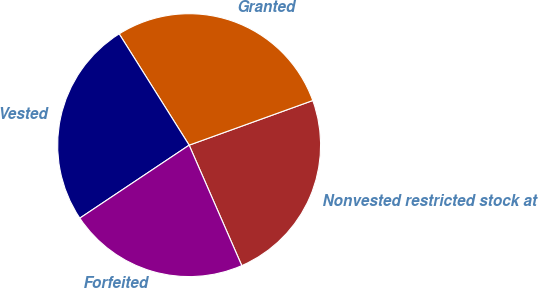<chart> <loc_0><loc_0><loc_500><loc_500><pie_chart><fcel>Nonvested restricted stock at<fcel>Granted<fcel>Vested<fcel>Forfeited<nl><fcel>23.96%<fcel>28.42%<fcel>25.44%<fcel>22.19%<nl></chart> 